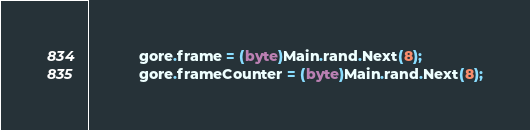<code> <loc_0><loc_0><loc_500><loc_500><_C#_>			gore.frame = (byte)Main.rand.Next(8);
			gore.frameCounter = (byte)Main.rand.Next(8);</code> 